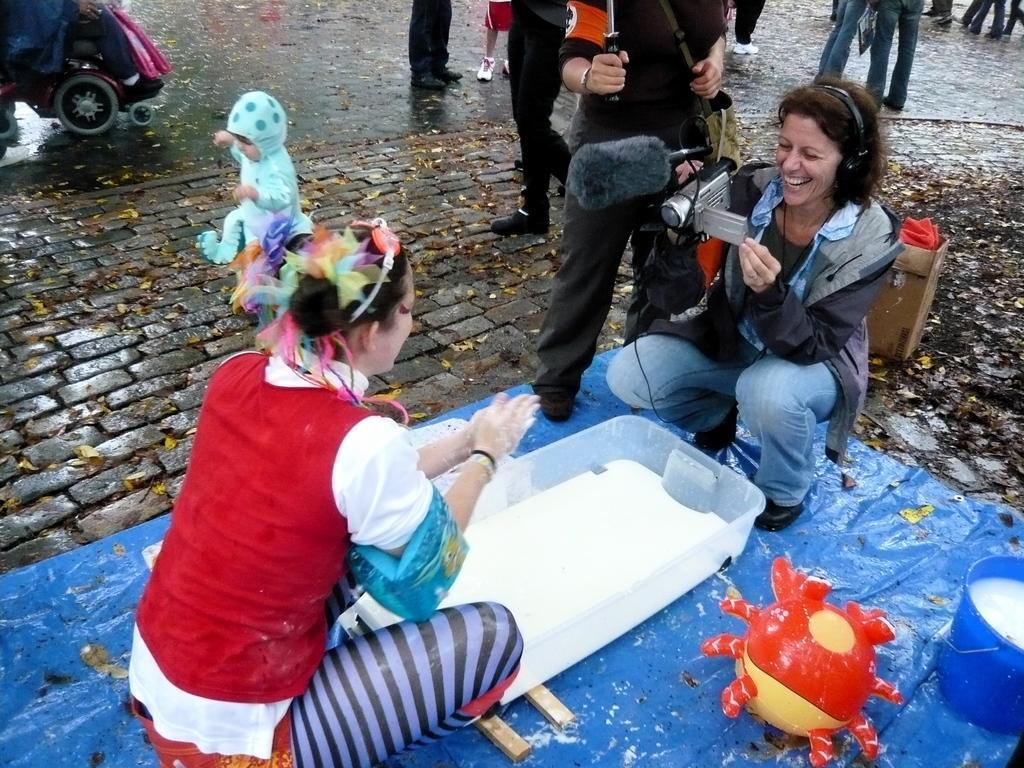Please provide a concise description of this image. In this image we can see , few people on the road, a person is holding a camera and a person is holding an object, there is a tub, a bucket, a toy on the blue color sheet and a person is sitting on the wheel chair and there is a box, and an object inside the box behind the person. 